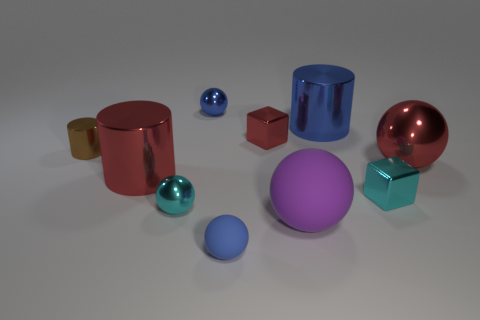How does the lighting in the scene affect the way we perceive the colors of the objects? The lighting in the scene is soft and diffused, allowing the colors of the objects to be seen clearly without harsh shadows. It gives the objects a gentle glow and highlights their reflective surfaces, which emphasizes their vivid colors. 